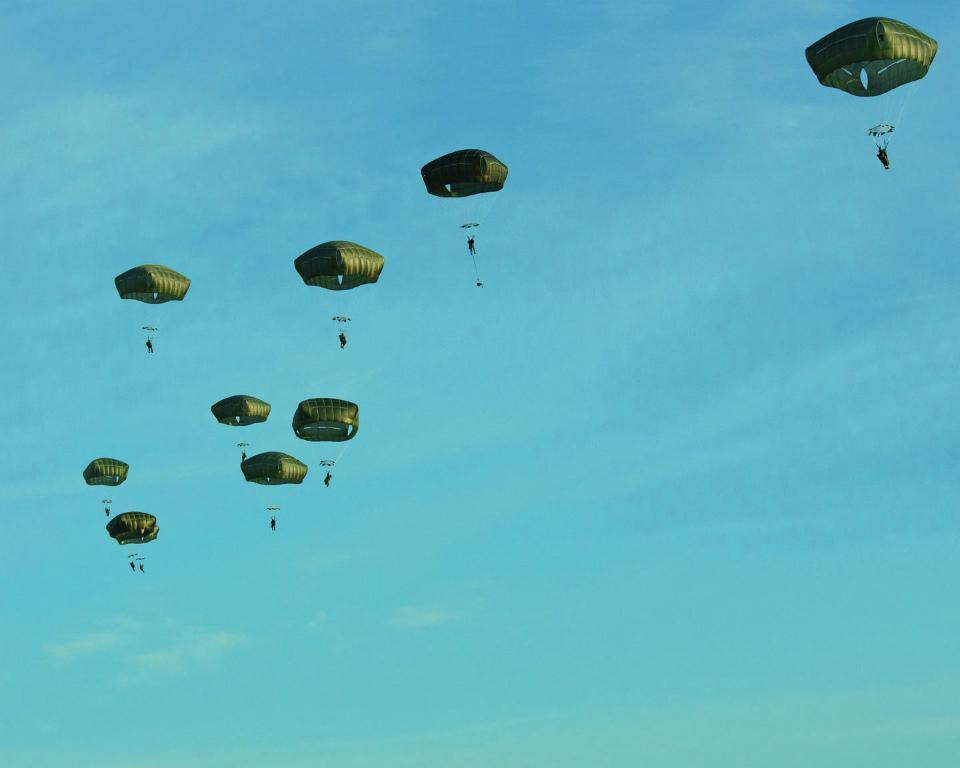What type of image is being described? The image is an animated picture. Where are the people located in the image? The people are in the center of the image. What objects are associated with the people in the image? There are parachutes in the image. What is the condition of the sky in the image? The sky is clear in the image. What type of flowers can be seen growing near the people in the image? There are no flowers present in the image; it features people with parachutes in a clear sky. 